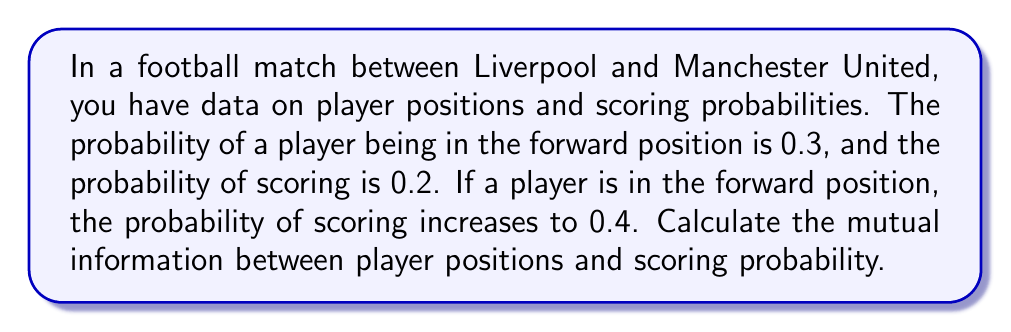What is the answer to this math problem? To calculate the mutual information between player positions and scoring probability, we need to follow these steps:

1) First, let's define our variables:
   X = Player Position (Forward or Not Forward)
   Y = Scoring (Score or Not Score)

2) We're given the following probabilities:
   P(X = Forward) = 0.3
   P(X = Not Forward) = 1 - 0.3 = 0.7
   P(Y = Score) = 0.2
   P(Y = Score | X = Forward) = 0.4

3) We can calculate P(Y = Score | X = Not Forward) using the law of total probability:
   P(Y = Score) = P(Y = Score | X = Forward) * P(X = Forward) + P(Y = Score | X = Not Forward) * P(X = Not Forward)
   0.2 = 0.4 * 0.3 + P(Y = Score | X = Not Forward) * 0.7
   P(Y = Score | X = Not Forward) = (0.2 - 0.4 * 0.3) / 0.7 ≈ 0.1143

4) Now we can create a joint probability distribution:
   P(X = Forward, Y = Score) = P(Y = Score | X = Forward) * P(X = Forward) = 0.4 * 0.3 = 0.12
   P(X = Forward, Y = Not Score) = P(X = Forward) - P(X = Forward, Y = Score) = 0.3 - 0.12 = 0.18
   P(X = Not Forward, Y = Score) = P(Y = Score | X = Not Forward) * P(X = Not Forward) ≈ 0.1143 * 0.7 = 0.08
   P(X = Not Forward, Y = Not Score) = P(X = Not Forward) - P(X = Not Forward, Y = Score) ≈ 0.7 - 0.08 = 0.62

5) The mutual information is calculated as:
   $$I(X;Y) = \sum_{x \in X} \sum_{y \in Y} P(x,y) \log_2 \frac{P(x,y)}{P(x)P(y)}$$

6) Let's calculate each term:
   $$0.12 \log_2 \frac{0.12}{0.3 * 0.2} \approx 0.1274$$
   $$0.18 \log_2 \frac{0.18}{0.3 * 0.8} \approx 0.0457$$
   $$0.08 \log_2 \frac{0.08}{0.7 * 0.2} \approx -0.0630$$
   $$0.62 \log_2 \frac{0.62}{0.7 * 0.8} \approx 0.0186$$

7) Sum all these terms:
   $$I(X;Y) \approx 0.1274 + 0.0457 - 0.0630 + 0.0186 \approx 0.1287$$ bits
Answer: The mutual information between player positions and scoring probability is approximately 0.1287 bits. 